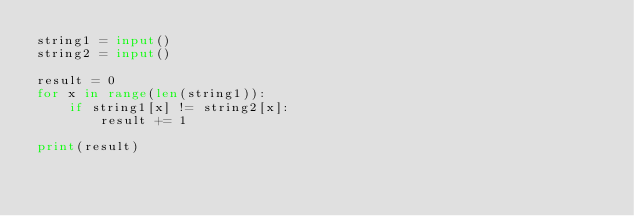Convert code to text. <code><loc_0><loc_0><loc_500><loc_500><_Python_>string1 = input()
string2 = input()

result = 0
for x in range(len(string1)):
    if string1[x] != string2[x]:
        result += 1

print(result)</code> 